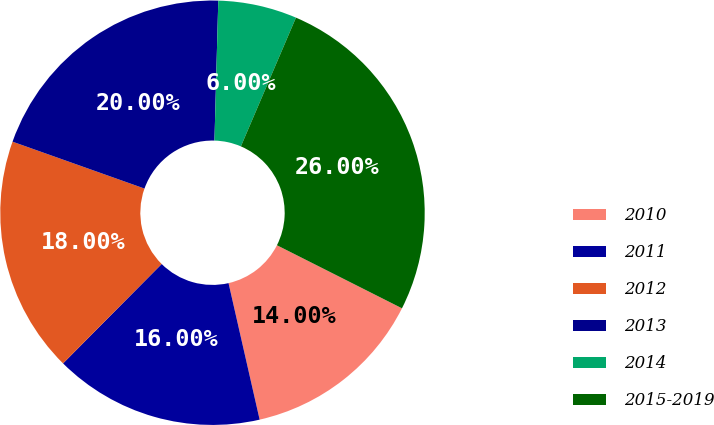Convert chart to OTSL. <chart><loc_0><loc_0><loc_500><loc_500><pie_chart><fcel>2010<fcel>2011<fcel>2012<fcel>2013<fcel>2014<fcel>2015-2019<nl><fcel>14.0%<fcel>16.0%<fcel>18.0%<fcel>20.0%<fcel>6.0%<fcel>26.0%<nl></chart> 